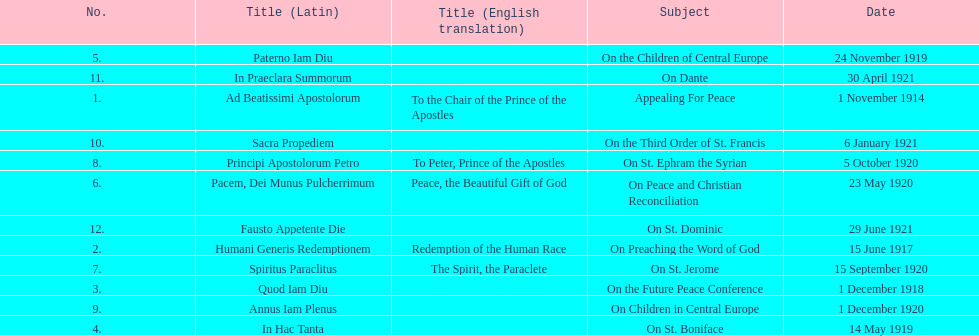What was the quantity of encyclopedias containing topics particularly focused on children? 2. 